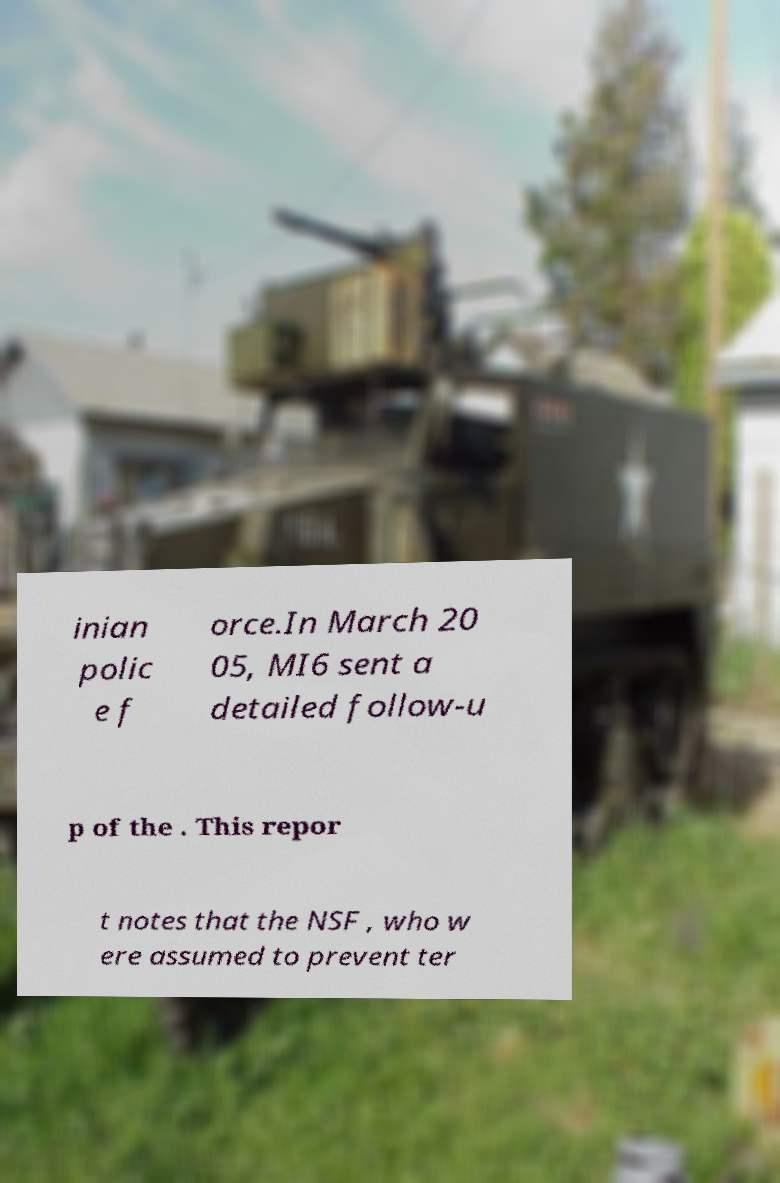There's text embedded in this image that I need extracted. Can you transcribe it verbatim? inian polic e f orce.In March 20 05, MI6 sent a detailed follow-u p of the . This repor t notes that the NSF , who w ere assumed to prevent ter 